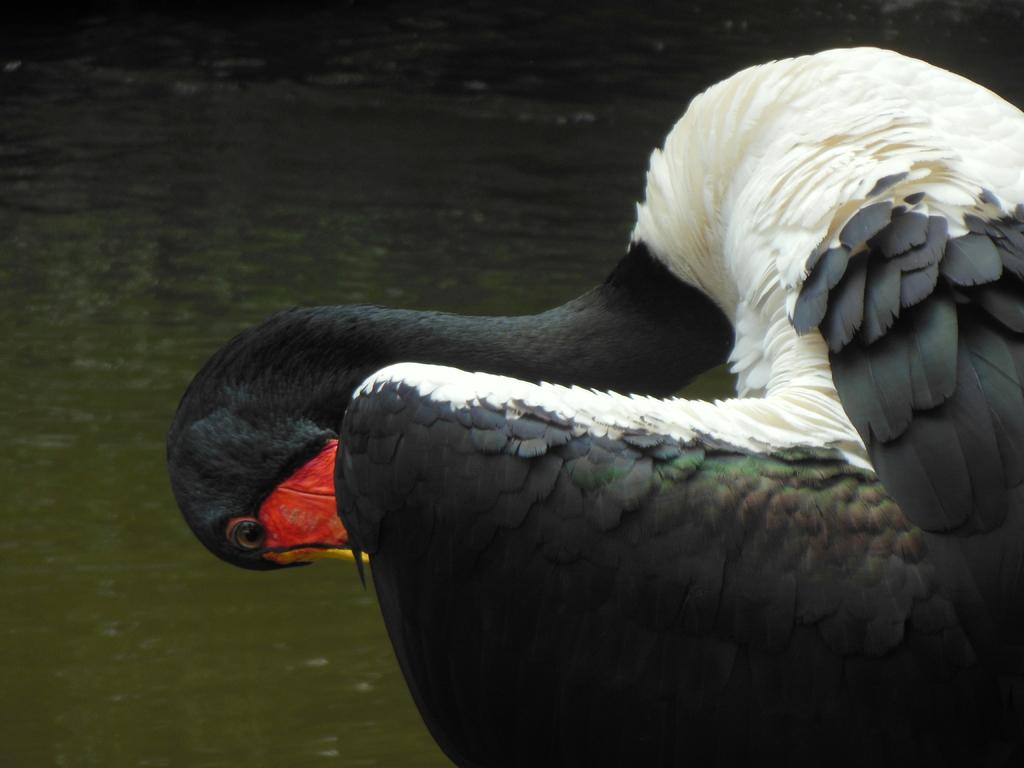What type of animal can be seen in the image? There is a bird in the image. What can be seen in the background of the image? There is water visible in the background of the image. What type of hook is the bird using to catch fish in the image? There is no hook present in the image, and the bird is not shown catching fish. 